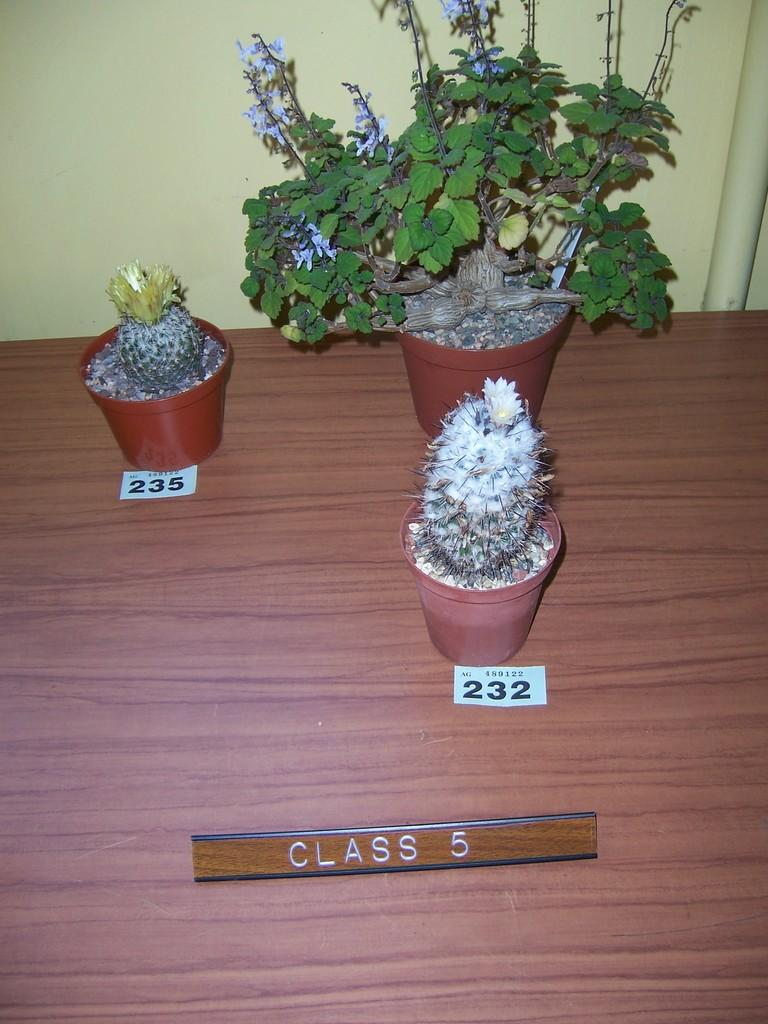What type of plants are in the image? There are plants in pots in the image. What is on the table in the image? There are papers and a name plate on the table in the image. What can be seen in the background of the image? There is a wall in the background of the image. What type of trip can be seen in the image? There is no trip present in the image; it features plants in pots, papers, a name plate, and a wall in the background. Can you see any fangs in the image? There are no fangs present in the image. 